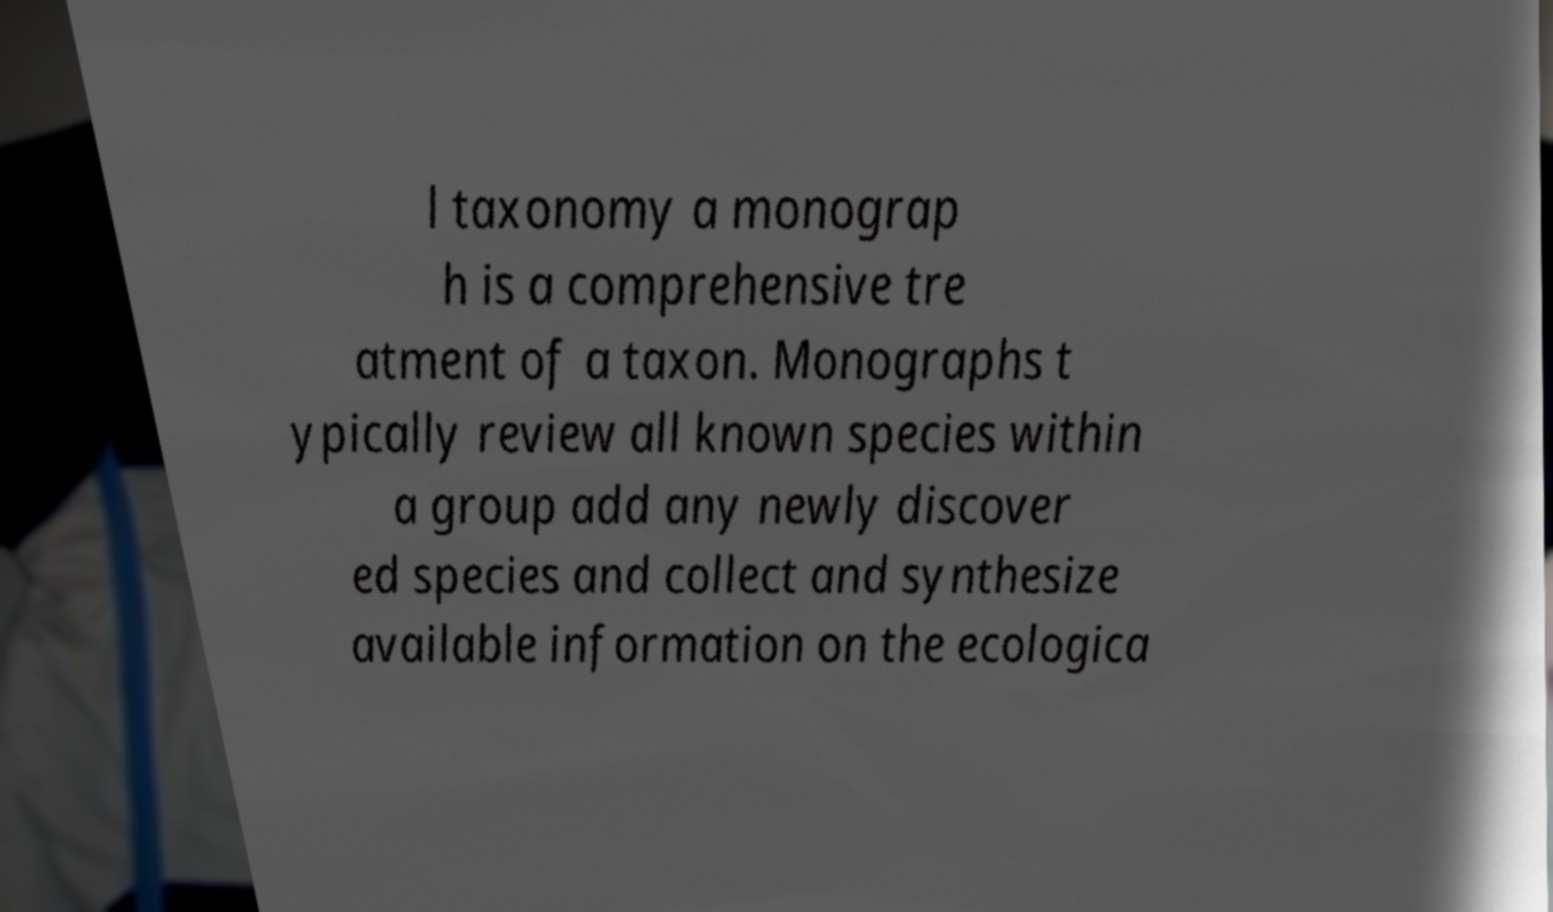There's text embedded in this image that I need extracted. Can you transcribe it verbatim? l taxonomy a monograp h is a comprehensive tre atment of a taxon. Monographs t ypically review all known species within a group add any newly discover ed species and collect and synthesize available information on the ecologica 